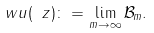<formula> <loc_0><loc_0><loc_500><loc_500>\ w u ( \ z ) \colon = \lim _ { m \to \infty } \mathcal { B } _ { m } .</formula> 